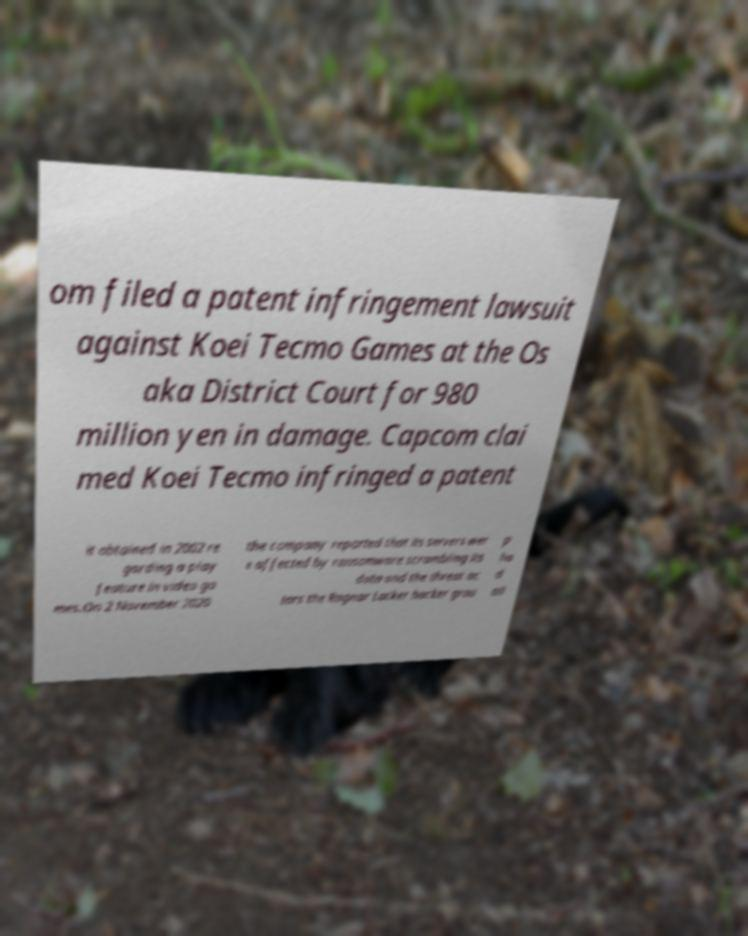Please identify and transcribe the text found in this image. om filed a patent infringement lawsuit against Koei Tecmo Games at the Os aka District Court for 980 million yen in damage. Capcom clai med Koei Tecmo infringed a patent it obtained in 2002 re garding a play feature in video ga mes.On 2 November 2020 the company reported that its servers wer e affected by ransomware scrambling its data and the threat ac tors the Ragnar Locker hacker grou p ha d all 